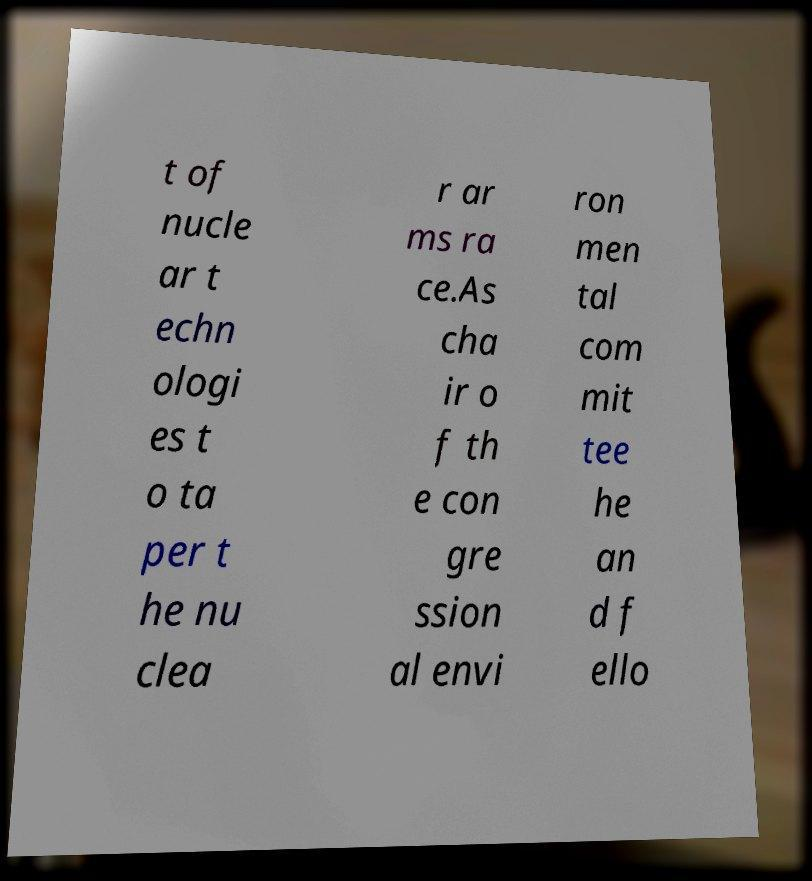Could you extract and type out the text from this image? t of nucle ar t echn ologi es t o ta per t he nu clea r ar ms ra ce.As cha ir o f th e con gre ssion al envi ron men tal com mit tee he an d f ello 